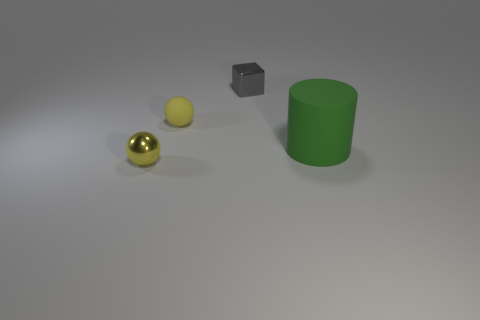Is there anything else that has the same size as the cylinder?
Keep it short and to the point. No. What number of other shiny things are the same shape as the tiny yellow metallic object?
Your response must be concise. 0. Is the number of small things on the left side of the small cube greater than the number of small yellow rubber objects in front of the shiny sphere?
Offer a very short reply. Yes. Does the tiny object in front of the rubber ball have the same color as the tiny cube?
Provide a succinct answer. No. How big is the cylinder?
Ensure brevity in your answer.  Large. What material is the other sphere that is the same size as the shiny ball?
Give a very brief answer. Rubber. There is a rubber object right of the gray object; what is its color?
Offer a very short reply. Green. What number of big purple matte spheres are there?
Give a very brief answer. 0. Is there a rubber ball that is on the left side of the small yellow object that is behind the yellow ball in front of the green rubber object?
Offer a very short reply. No. There is a yellow thing that is the same size as the shiny sphere; what is its shape?
Ensure brevity in your answer.  Sphere. 